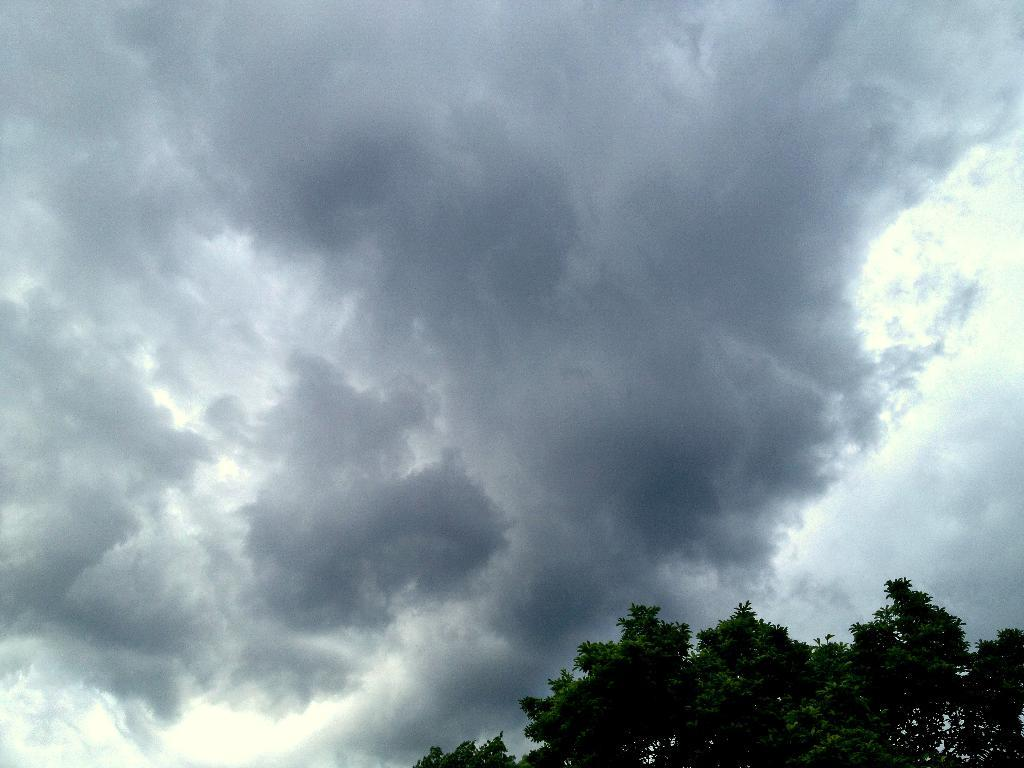What type of natural elements can be seen in the image? There are many trees and clouds visible in the image. What part of the natural environment is visible in the image? The sky is visible in the image. What type of key is used to unlock the stage in the image? There is no stage or key present in the image; it features trees, clouds, and the sky. How many ducks can be seen swimming in the image? There are no ducks present in the image. 